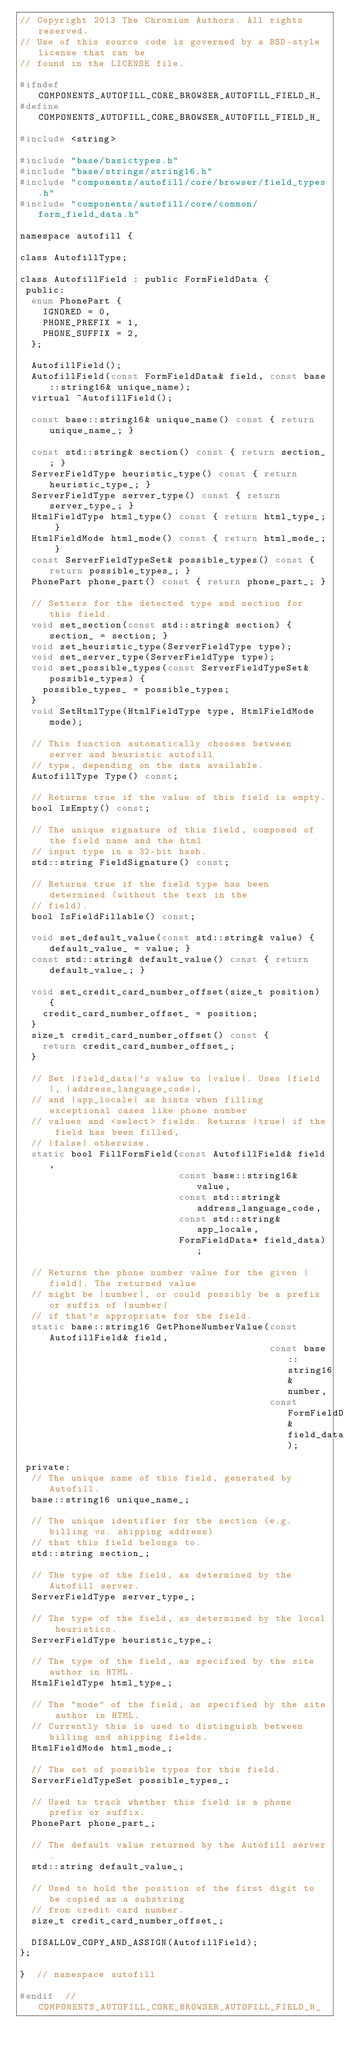Convert code to text. <code><loc_0><loc_0><loc_500><loc_500><_C_>// Copyright 2013 The Chromium Authors. All rights reserved.
// Use of this source code is governed by a BSD-style license that can be
// found in the LICENSE file.

#ifndef COMPONENTS_AUTOFILL_CORE_BROWSER_AUTOFILL_FIELD_H_
#define COMPONENTS_AUTOFILL_CORE_BROWSER_AUTOFILL_FIELD_H_

#include <string>

#include "base/basictypes.h"
#include "base/strings/string16.h"
#include "components/autofill/core/browser/field_types.h"
#include "components/autofill/core/common/form_field_data.h"

namespace autofill {

class AutofillType;

class AutofillField : public FormFieldData {
 public:
  enum PhonePart {
    IGNORED = 0,
    PHONE_PREFIX = 1,
    PHONE_SUFFIX = 2,
  };

  AutofillField();
  AutofillField(const FormFieldData& field, const base::string16& unique_name);
  virtual ~AutofillField();

  const base::string16& unique_name() const { return unique_name_; }

  const std::string& section() const { return section_; }
  ServerFieldType heuristic_type() const { return heuristic_type_; }
  ServerFieldType server_type() const { return server_type_; }
  HtmlFieldType html_type() const { return html_type_; }
  HtmlFieldMode html_mode() const { return html_mode_; }
  const ServerFieldTypeSet& possible_types() const { return possible_types_; }
  PhonePart phone_part() const { return phone_part_; }

  // Setters for the detected type and section for this field.
  void set_section(const std::string& section) { section_ = section; }
  void set_heuristic_type(ServerFieldType type);
  void set_server_type(ServerFieldType type);
  void set_possible_types(const ServerFieldTypeSet& possible_types) {
    possible_types_ = possible_types;
  }
  void SetHtmlType(HtmlFieldType type, HtmlFieldMode mode);

  // This function automatically chooses between server and heuristic autofill
  // type, depending on the data available.
  AutofillType Type() const;

  // Returns true if the value of this field is empty.
  bool IsEmpty() const;

  // The unique signature of this field, composed of the field name and the html
  // input type in a 32-bit hash.
  std::string FieldSignature() const;

  // Returns true if the field type has been determined (without the text in the
  // field).
  bool IsFieldFillable() const;

  void set_default_value(const std::string& value) { default_value_ = value; }
  const std::string& default_value() const { return default_value_; }

  void set_credit_card_number_offset(size_t position) {
    credit_card_number_offset_ = position;
  }
  size_t credit_card_number_offset() const {
    return credit_card_number_offset_;
  }

  // Set |field_data|'s value to |value|. Uses |field|, |address_language_code|,
  // and |app_locale| as hints when filling exceptional cases like phone number
  // values and <select> fields. Returns |true| if the field has been filled,
  // |false| otherwise.
  static bool FillFormField(const AutofillField& field,
                            const base::string16& value,
                            const std::string& address_language_code,
                            const std::string& app_locale,
                            FormFieldData* field_data);

  // Returns the phone number value for the given |field|. The returned value
  // might be |number|, or could possibly be a prefix or suffix of |number|
  // if that's appropriate for the field.
  static base::string16 GetPhoneNumberValue(const AutofillField& field,
                                            const base::string16& number,
                                            const FormFieldData& field_data);

 private:
  // The unique name of this field, generated by Autofill.
  base::string16 unique_name_;

  // The unique identifier for the section (e.g. billing vs. shipping address)
  // that this field belongs to.
  std::string section_;

  // The type of the field, as determined by the Autofill server.
  ServerFieldType server_type_;

  // The type of the field, as determined by the local heuristics.
  ServerFieldType heuristic_type_;

  // The type of the field, as specified by the site author in HTML.
  HtmlFieldType html_type_;

  // The "mode" of the field, as specified by the site author in HTML.
  // Currently this is used to distinguish between billing and shipping fields.
  HtmlFieldMode html_mode_;

  // The set of possible types for this field.
  ServerFieldTypeSet possible_types_;

  // Used to track whether this field is a phone prefix or suffix.
  PhonePart phone_part_;

  // The default value returned by the Autofill server.
  std::string default_value_;

  // Used to hold the position of the first digit to be copied as a substring
  // from credit card number.
  size_t credit_card_number_offset_;

  DISALLOW_COPY_AND_ASSIGN(AutofillField);
};

}  // namespace autofill

#endif  // COMPONENTS_AUTOFILL_CORE_BROWSER_AUTOFILL_FIELD_H_
</code> 